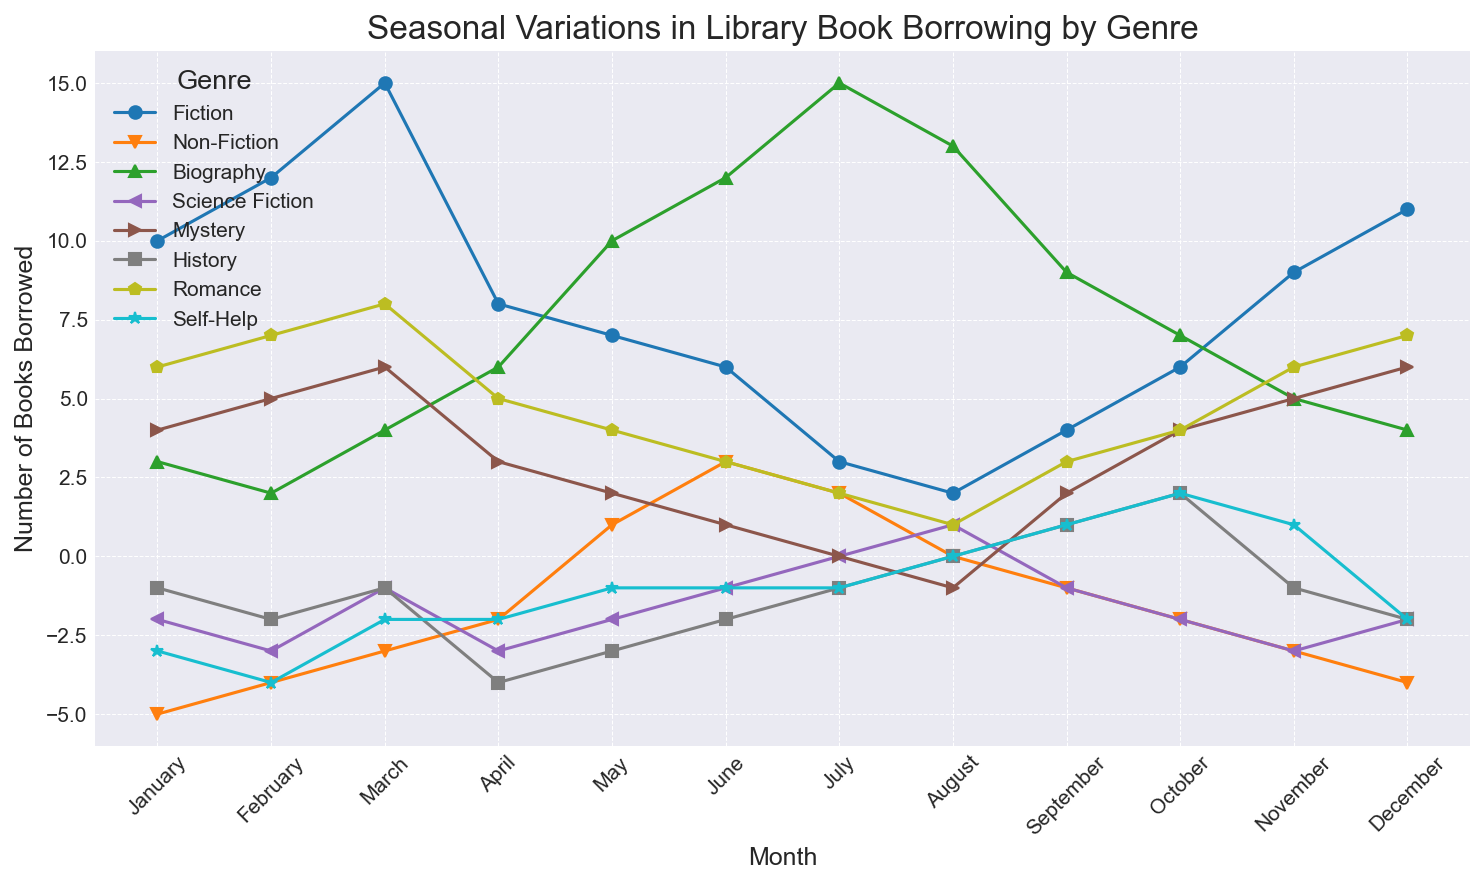What month had the highest borrowing for Fiction? By looking at the 'Fiction' line, identify the point with the highest value. The peak value for Fiction appears in March.
Answer: March Which genre experienced the most borrowing in July? Examine all the lines to see which one is highest in July. The peak in July is for 'Biography' with a value of 15.
Answer: Biography Which genres have consistently negative borrowing values? Look at the lines for any genre that remains below the x-axis throughout all months. 'Science Fiction' and 'Self-Help' have consistently negative values.
Answer: Science Fiction and Self-Help What is the total number of books borrowed for Mystery in the first quarter (January to March)? Sum up the values for 'Mystery' from January to March: 4 + 5 + 6 = 15.
Answer: 15 Does Romance borrowing increase or decrease from June to August? Trace the 'Romance' line from June (3), July (2), to August (1); it is a decreasing trend.
Answer: Decrease In which month does Non-Fiction reach its highest borrowing? Observe the 'Non-Fiction' line and identify the month with the highest peak. Non-Fiction peaks in June with a value of 3.
Answer: June Which genre has the widest fluctuation range in values through the year? Check the maximum and minimum values for each genre. 'Biography' ranges from 3 to 15, showing the widest fluctuation.
Answer: Biography How does History borrowing compare between January and December? Compare the 'History' values for January (-1) and December (-2). Borrowing is slightly less in December.
Answer: Decreases What is the average number of books borrowed for Science Fiction over the year? Sum all monthly values for 'Science Fiction' and then divide by 12: (-2 - 3 - 1 - 3 - 2 - 1 + 0 + 1 - 1 - 2 - 3 - 2) / 12 = -19 / 12 ≈ -1.58.
Answer: -1.58 Which genre shows the most positive borrowing trend (increasing throughout the year)? Identify the line that generally trends upwards. 'Non-Fiction' shows an upward trend overall.
Answer: Non-Fiction 